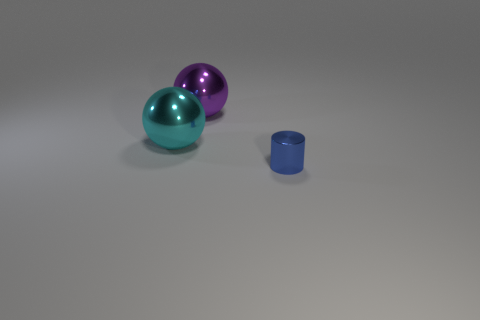Add 1 big cyan balls. How many objects exist? 4 Subtract all balls. How many objects are left? 1 Subtract all purple things. Subtract all tiny metal things. How many objects are left? 1 Add 2 large balls. How many large balls are left? 4 Add 1 blue metallic cylinders. How many blue metallic cylinders exist? 2 Subtract 0 green cubes. How many objects are left? 3 